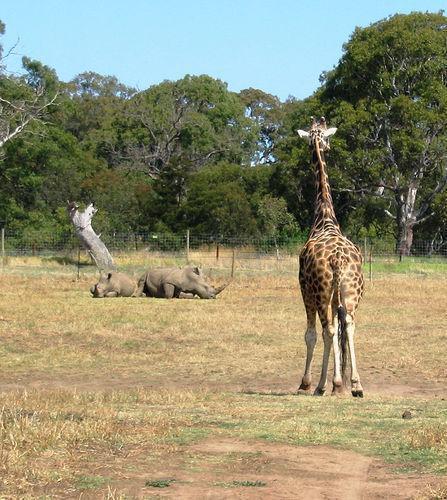How many rhinos in the field?
Give a very brief answer. 2. How many species are seen?
Give a very brief answer. 2. How many giraffes can you see?
Give a very brief answer. 1. 